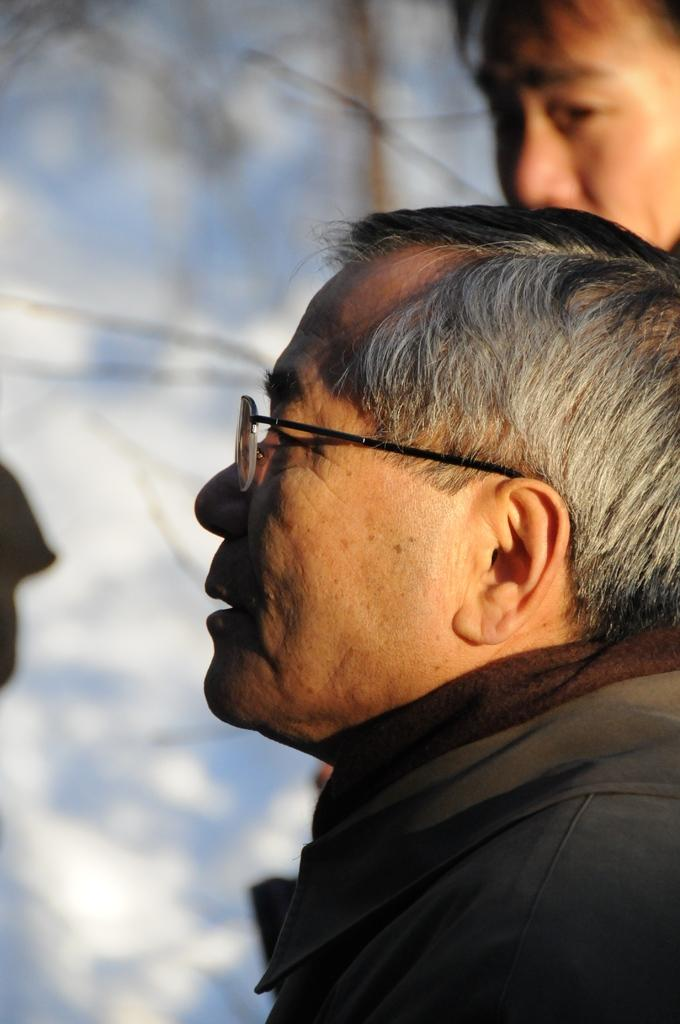How many people are in the image? There are two persons in the image. Can you describe any specific features of one of the persons? One of the persons is wearing spectacles. What can be observed about the background of the image? The background of the image is blurred. What type of wine is being poured into a glass in the image? There is no wine or glass present in the image; it only features two persons and a blurred background. 